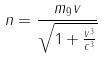<formula> <loc_0><loc_0><loc_500><loc_500>n = \frac { m _ { 9 } v } { \sqrt { 1 + \frac { v ^ { 3 } } { c ^ { 3 } } } }</formula> 